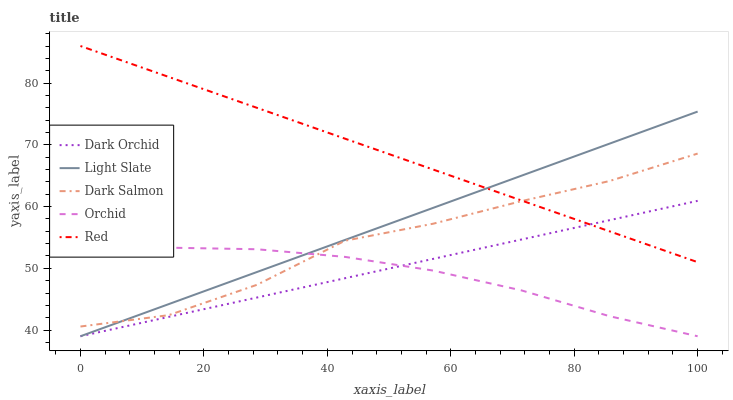Does Orchid have the minimum area under the curve?
Answer yes or no. Yes. Does Red have the maximum area under the curve?
Answer yes or no. Yes. Does Dark Salmon have the minimum area under the curve?
Answer yes or no. No. Does Dark Salmon have the maximum area under the curve?
Answer yes or no. No. Is Dark Orchid the smoothest?
Answer yes or no. Yes. Is Dark Salmon the roughest?
Answer yes or no. Yes. Is Red the smoothest?
Answer yes or no. No. Is Red the roughest?
Answer yes or no. No. Does Light Slate have the lowest value?
Answer yes or no. Yes. Does Dark Salmon have the lowest value?
Answer yes or no. No. Does Red have the highest value?
Answer yes or no. Yes. Does Dark Salmon have the highest value?
Answer yes or no. No. Is Orchid less than Red?
Answer yes or no. Yes. Is Dark Salmon greater than Dark Orchid?
Answer yes or no. Yes. Does Orchid intersect Dark Orchid?
Answer yes or no. Yes. Is Orchid less than Dark Orchid?
Answer yes or no. No. Is Orchid greater than Dark Orchid?
Answer yes or no. No. Does Orchid intersect Red?
Answer yes or no. No. 